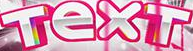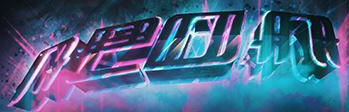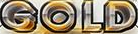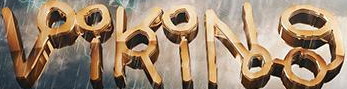Read the text content from these images in order, separated by a semicolon. TexT; neon; GOLD; VikiNg 